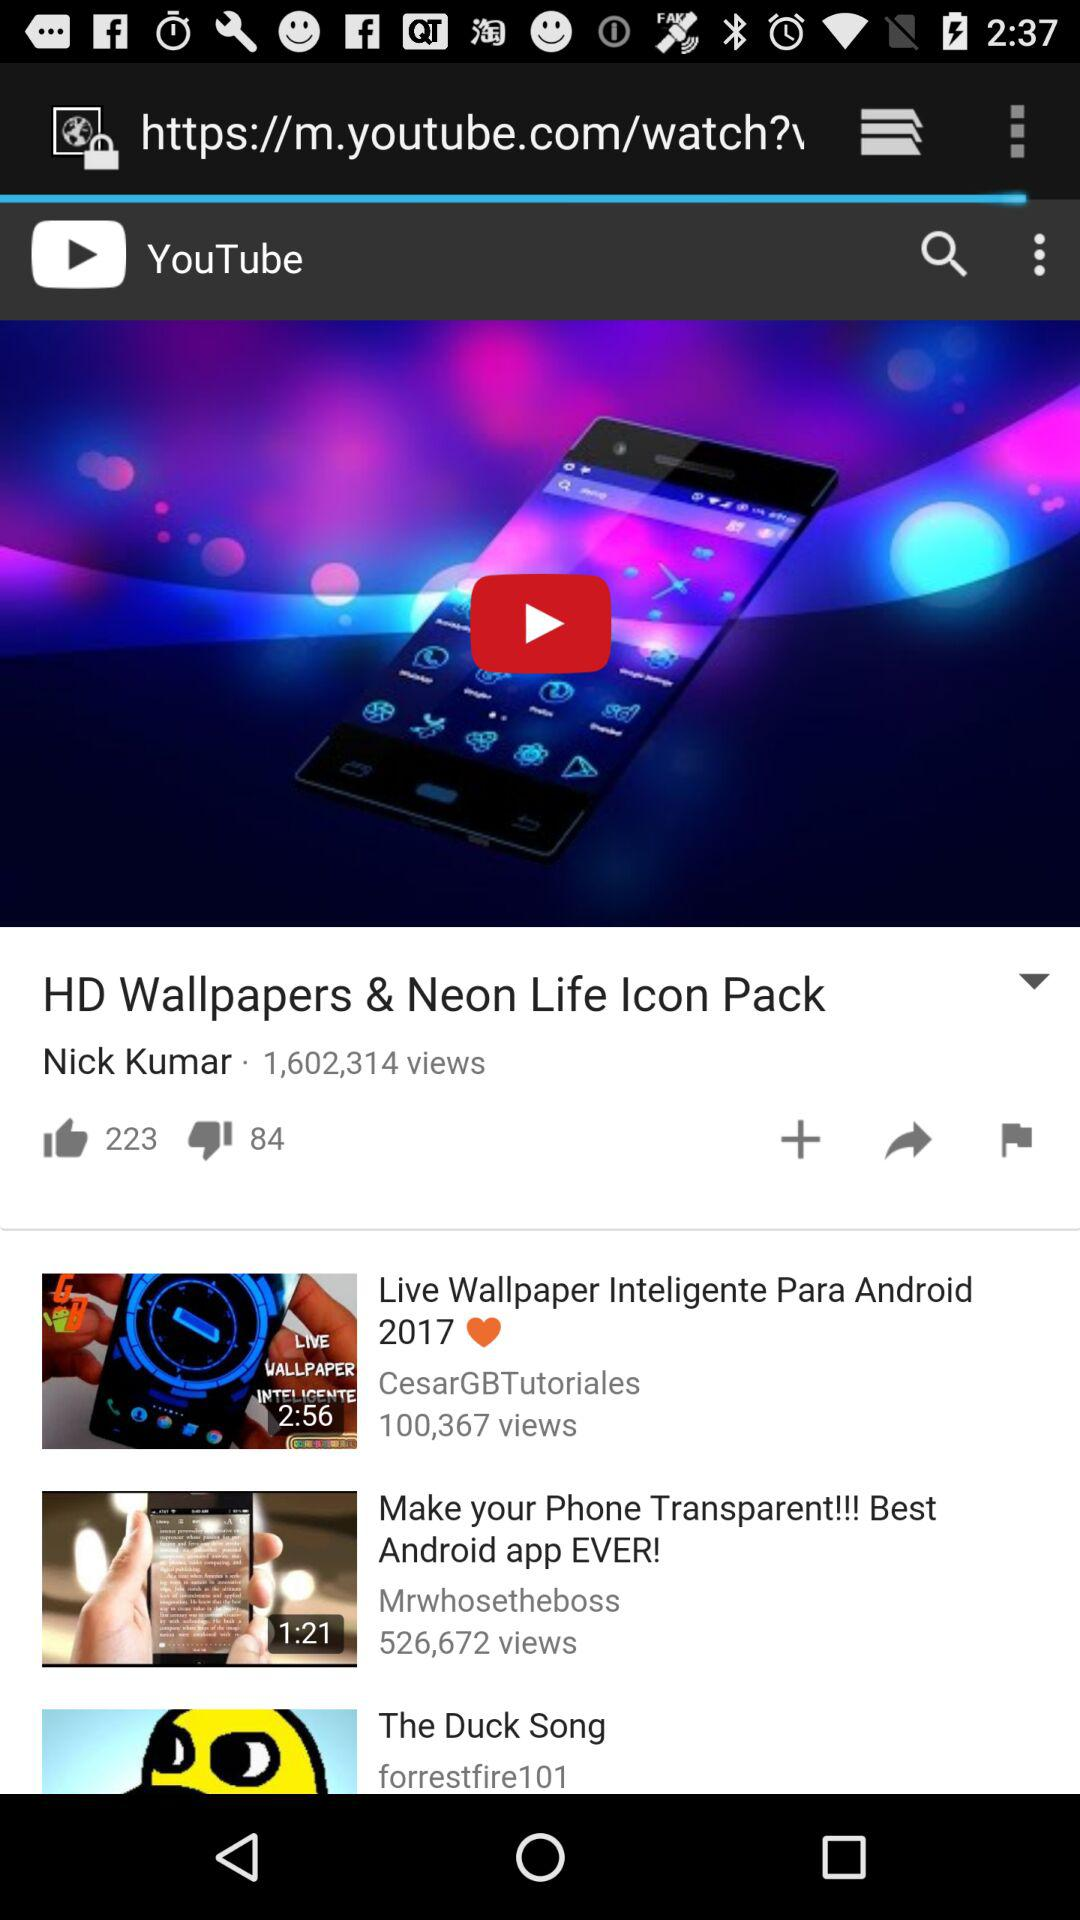How many dislikes are there? There are 84 dislikes. 